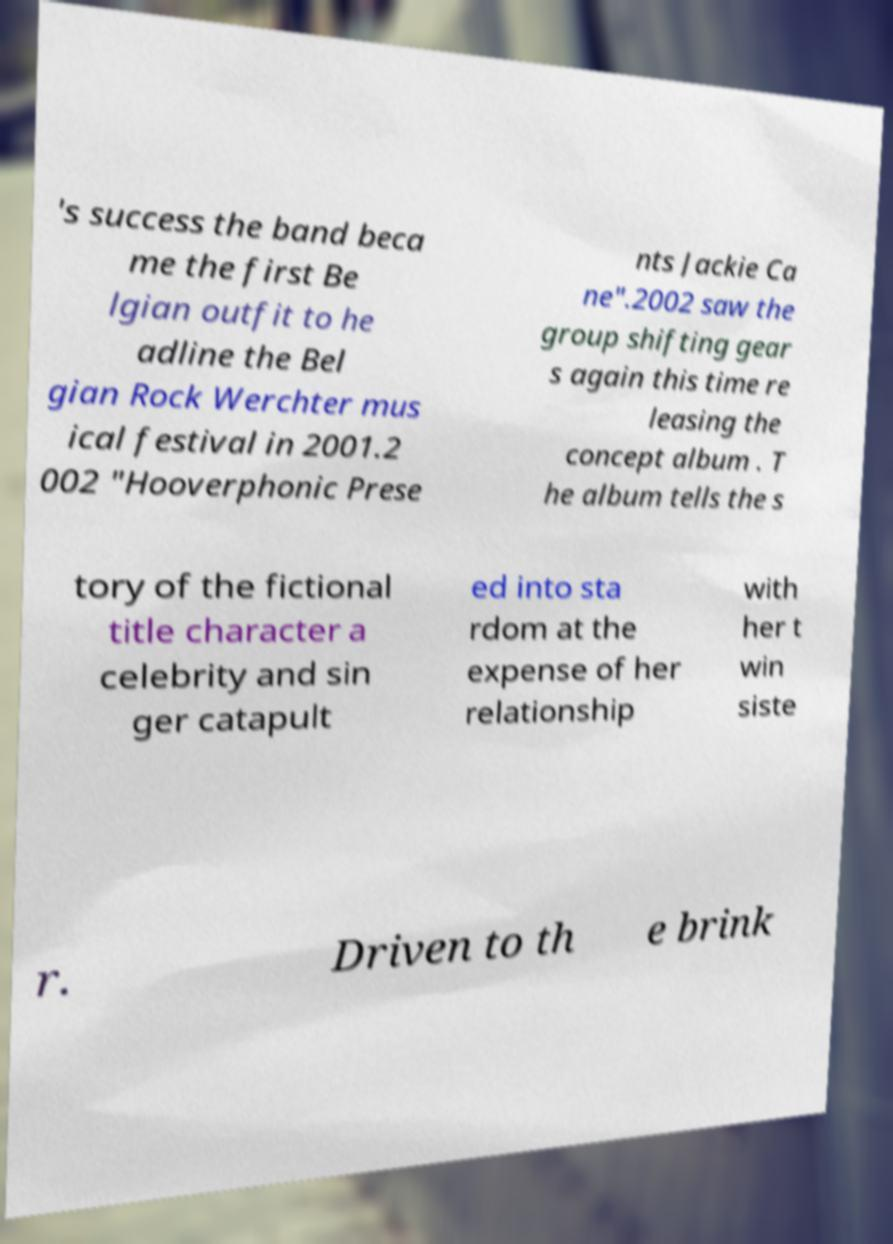Could you extract and type out the text from this image? 's success the band beca me the first Be lgian outfit to he adline the Bel gian Rock Werchter mus ical festival in 2001.2 002 "Hooverphonic Prese nts Jackie Ca ne".2002 saw the group shifting gear s again this time re leasing the concept album . T he album tells the s tory of the fictional title character a celebrity and sin ger catapult ed into sta rdom at the expense of her relationship with her t win siste r. Driven to th e brink 